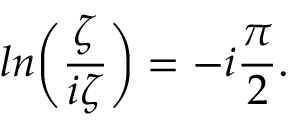<formula> <loc_0><loc_0><loc_500><loc_500>\ln \left ( { \frac { \zeta } { i \zeta } } \right ) = - i { \frac { \pi } { 2 } } .</formula> 